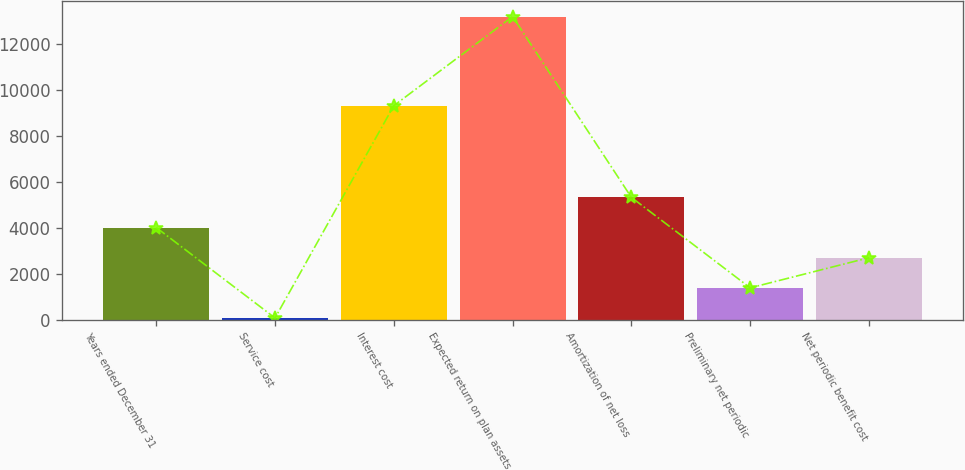Convert chart to OTSL. <chart><loc_0><loc_0><loc_500><loc_500><bar_chart><fcel>Years ended December 31<fcel>Service cost<fcel>Interest cost<fcel>Expected return on plan assets<fcel>Amortization of net loss<fcel>Preliminary net periodic<fcel>Net periodic benefit cost<nl><fcel>4015.4<fcel>71<fcel>9331<fcel>13219<fcel>5330.2<fcel>1385.8<fcel>2700.6<nl></chart> 